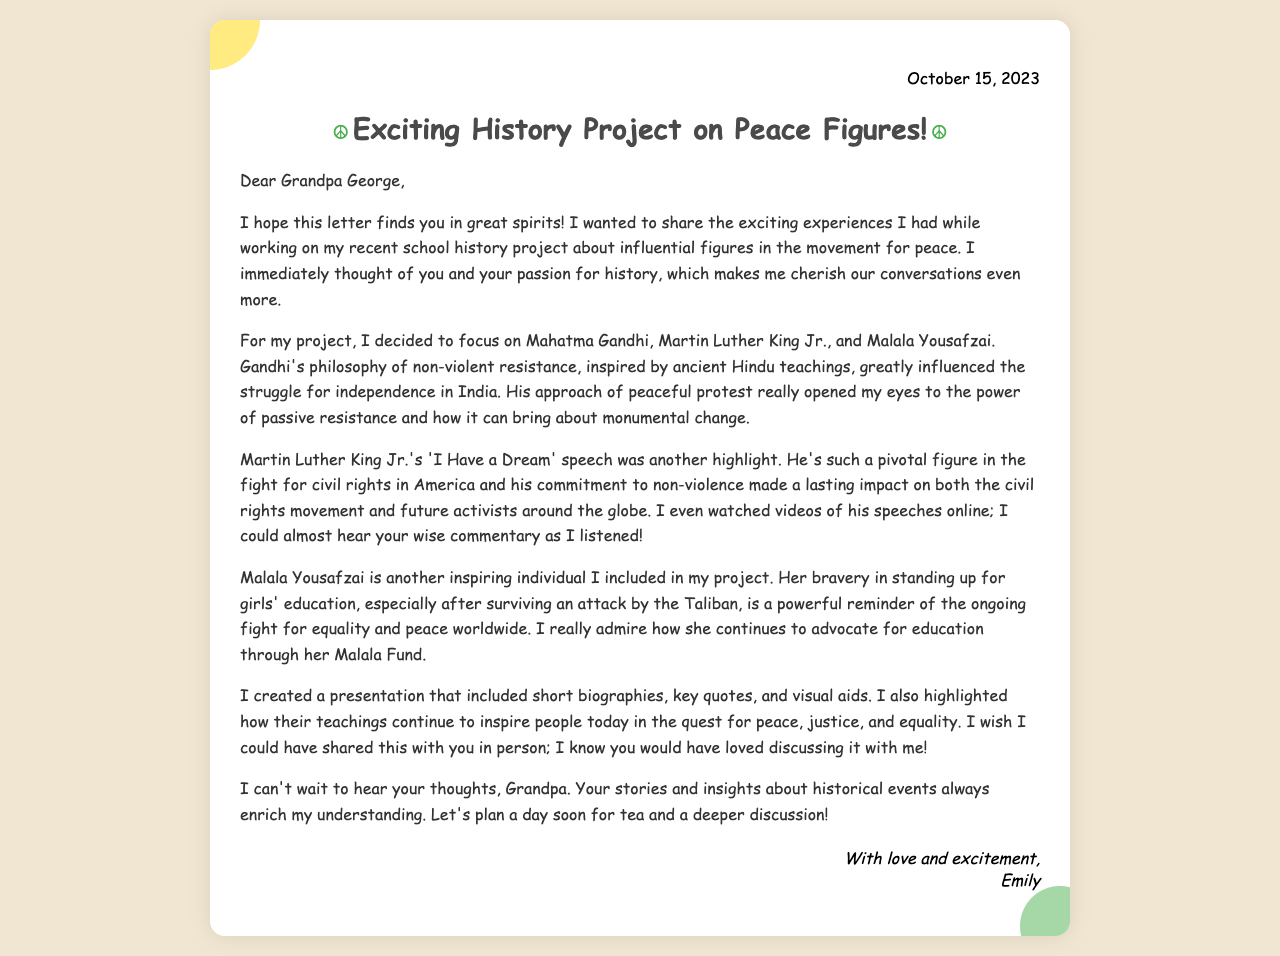What date was the letter written? The letter is dated October 15, 2023, as noted in the header of the document.
Answer: October 15, 2023 Who are the three influential figures mentioned in the project? The letter lists Mahatma Gandhi, Martin Luther King Jr., and Malala Yousafzai as the figures focused on in the project.
Answer: Mahatma Gandhi, Martin Luther King Jr., Malala Yousafzai What was the major theme of Emily's project? The project centered around influential figures in the movement for peace, highlighting their contributions and philosophies.
Answer: Peace What significant speech of Martin Luther King Jr. is mentioned? Emily refers to the 'I Have a Dream' speech, which was pivotal in the civil rights movement.
Answer: 'I Have a Dream' What platform did Malala Yousafzai advocate for? Emily notes that Malala advocates for girls' education through her Malala Fund.
Answer: Girls' education What did Emily create for her project? She created a presentation that included short biographies, key quotes, and visual aids.
Answer: A presentation What type of tone does the letter convey? The letter's tone is warm and enthusiastic, indicating Emily's excitement to share her project.
Answer: Warm and enthusiastic How does Emily feel about sharing the project with her grandfather? Emily expresses a longing to share her project in person, indicating she values his insights and discussions.
Answer: She wishes she could share it in person 